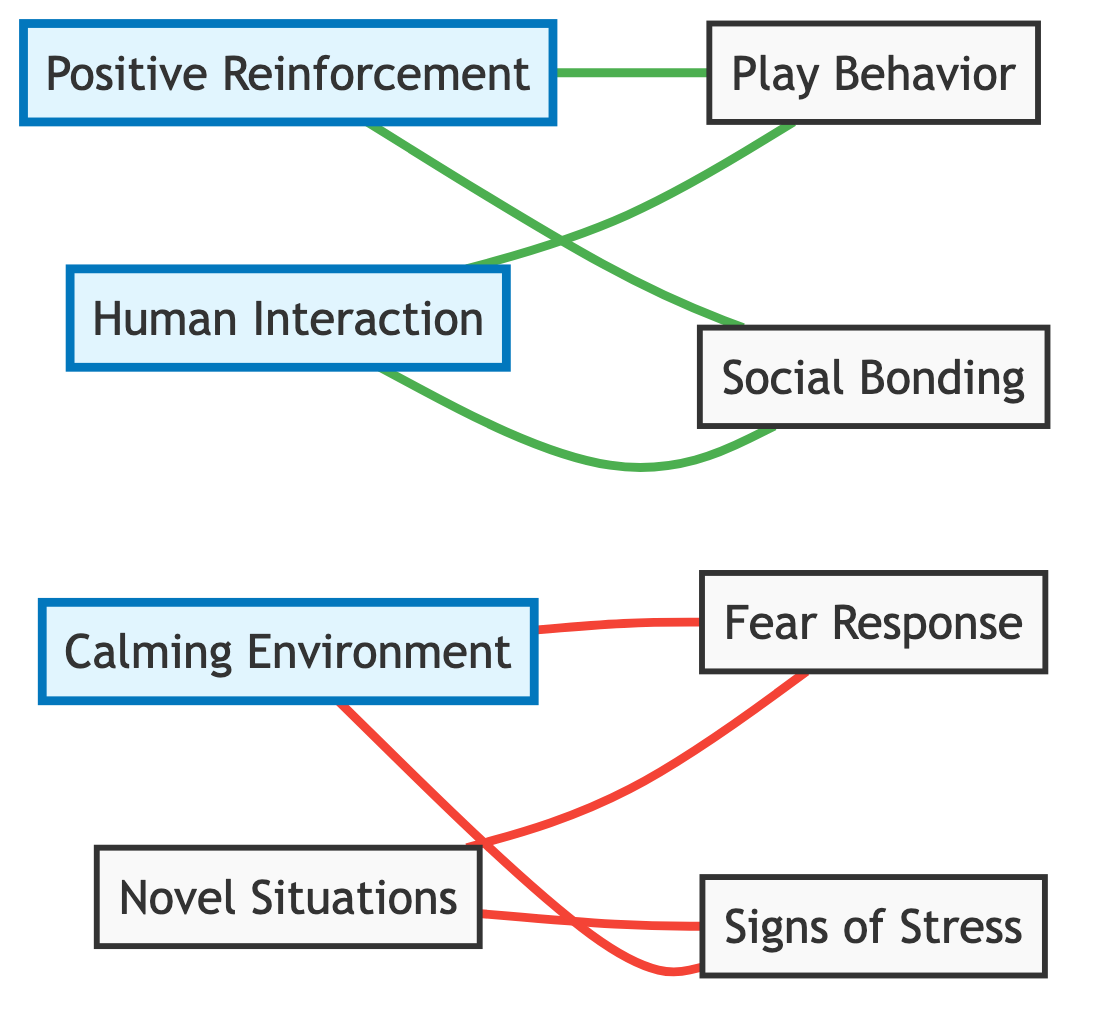What is the total number of nodes in the graph? The graph contains eight different nodes, which are listed as Positive Reinforcement, Fear Response, Calming Environment, Play Behavior, Human Interaction, Social Bonding, Novel Situations, and Signs of Stress.
Answer: 8 Which node is connected to Fear Response? Fear Response is connected to Calming Environment and Novel Situations, as indicated by two edges coming from these nodes towards Fear Response.
Answer: Calming Environment, Novel Situations How many edges are there in total? There are a total of eight edges in the graph, as counted from the connections between the nodes.
Answer: 8 Which behavior can be influenced by Positive Reinforcement? Positive Reinforcement is connected to both Play Behavior and Social Bonding, indicating that it can influence these behaviors.
Answer: Play Behavior, Social Bonding What is the relationship between Calming Environment and Signs of Stress? Calming Environment is connected to Signs of Stress through one edge, indicating a direct relationship where a calming environment may influence or reduce signs of stress.
Answer: Connected Which factors are linked to Novel Situations? Novel Situations are linked to Fear Response and Signs of Stress, as shown by the edges leading from Novel Situations to these two nodes.
Answer: Fear Response, Signs of Stress How many connections does Human Interaction have? Human Interaction has two connections: one to Social Bonding and another to Play Behavior, making a total of two connections.
Answer: 2 What type of response does a Calming Environment affect? A Calming Environment affects two responses: it leads to a reduction in Fear Response and Signs of Stress, as indicated by the connections in the graph.
Answer: Fear Response, Signs of Stress 